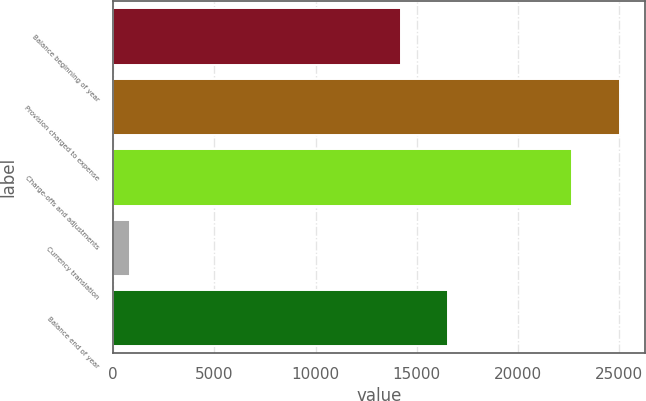Convert chart. <chart><loc_0><loc_0><loc_500><loc_500><bar_chart><fcel>Balance beginning of year<fcel>Provision charged to expense<fcel>Charge-offs and adjustments<fcel>Currency translation<fcel>Balance end of year<nl><fcel>14212<fcel>25030.4<fcel>22682<fcel>840<fcel>16560.4<nl></chart> 